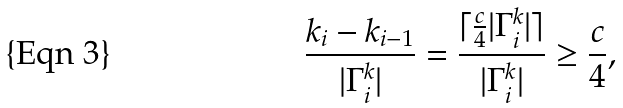Convert formula to latex. <formula><loc_0><loc_0><loc_500><loc_500>\frac { k _ { i } - k _ { i - 1 } } { | { \Gamma } ^ { k } _ { i } | } = \frac { \lceil \frac { c } { 4 } | { \Gamma } ^ { k } _ { i } | \rceil } { | { \Gamma } ^ { k } _ { i } | } \geq \frac { c } { 4 } ,</formula> 